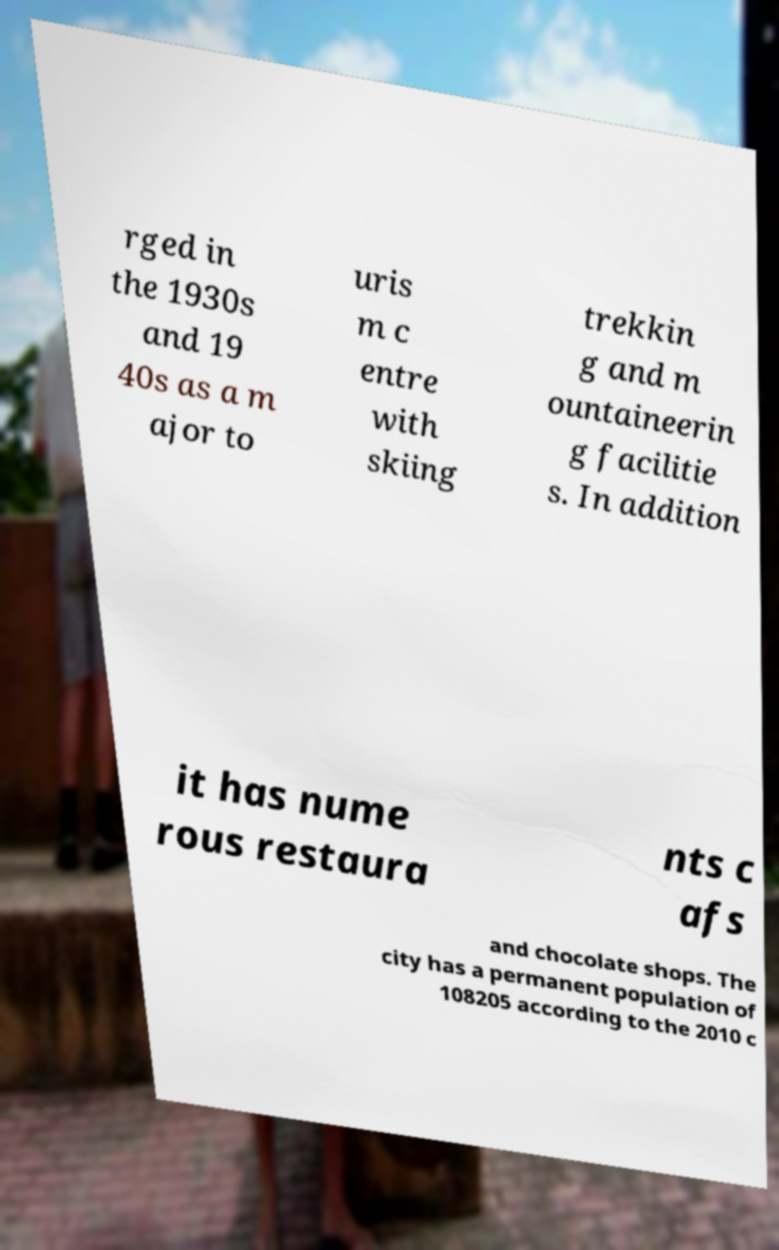Can you read and provide the text displayed in the image?This photo seems to have some interesting text. Can you extract and type it out for me? rged in the 1930s and 19 40s as a m ajor to uris m c entre with skiing trekkin g and m ountaineerin g facilitie s. In addition it has nume rous restaura nts c afs and chocolate shops. The city has a permanent population of 108205 according to the 2010 c 